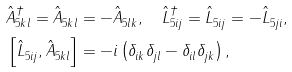Convert formula to latex. <formula><loc_0><loc_0><loc_500><loc_500>& \hat { A } ^ { \dag } _ { 5 k l } = \hat { A } ^ { \ } _ { 5 k l } = - \hat { A } ^ { \ } _ { 5 l k } , \quad \hat { L } ^ { \dag } _ { 5 i j } = \hat { L } ^ { \ } _ { 5 i j } = - \hat { L } ^ { \ } _ { 5 j i } , \\ & \left [ \hat { L } ^ { \ } _ { 5 i j } , \hat { A } ^ { \ } _ { 5 k l } \right ] = - { i } \left ( \delta ^ { \ } _ { i k } \delta ^ { \ } _ { j l } - \delta ^ { \ } _ { i l } \delta ^ { \ } _ { j k } \right ) ,</formula> 